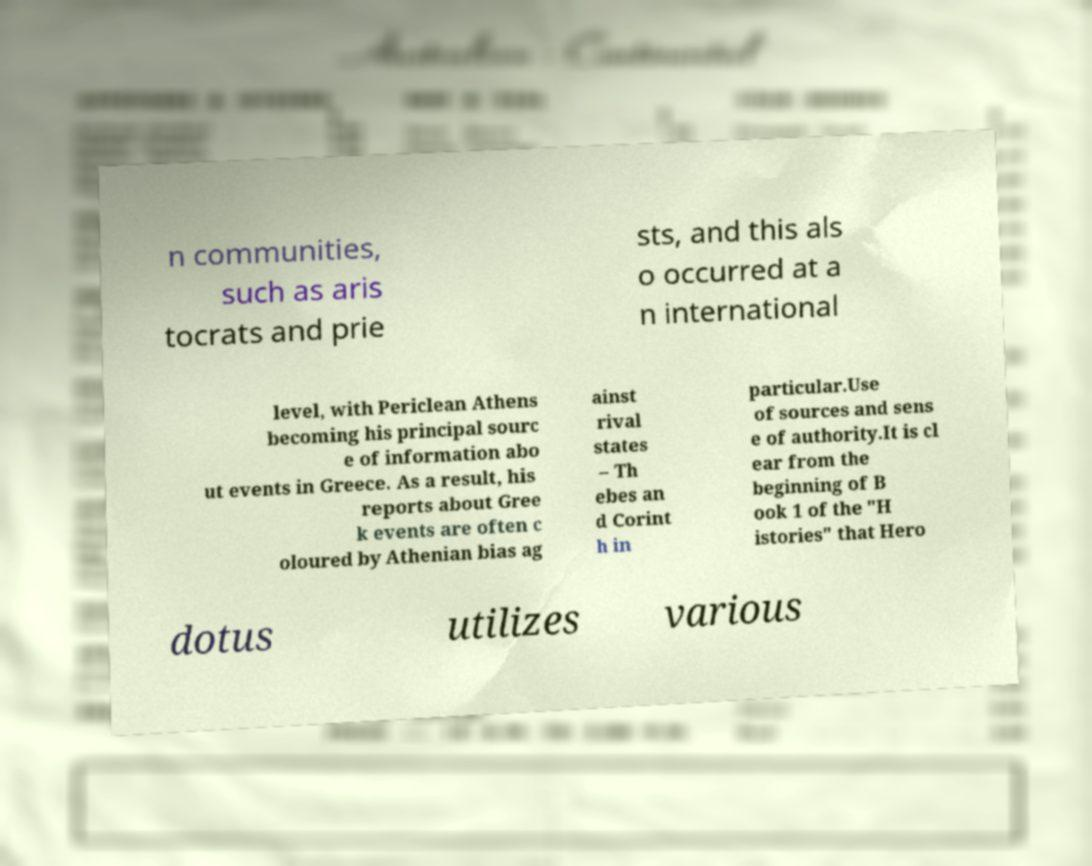Can you read and provide the text displayed in the image?This photo seems to have some interesting text. Can you extract and type it out for me? n communities, such as aris tocrats and prie sts, and this als o occurred at a n international level, with Periclean Athens becoming his principal sourc e of information abo ut events in Greece. As a result, his reports about Gree k events are often c oloured by Athenian bias ag ainst rival states – Th ebes an d Corint h in particular.Use of sources and sens e of authority.It is cl ear from the beginning of B ook 1 of the "H istories" that Hero dotus utilizes various 